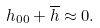Convert formula to latex. <formula><loc_0><loc_0><loc_500><loc_500>h _ { 0 0 } + \overline { h } \approx 0 .</formula> 